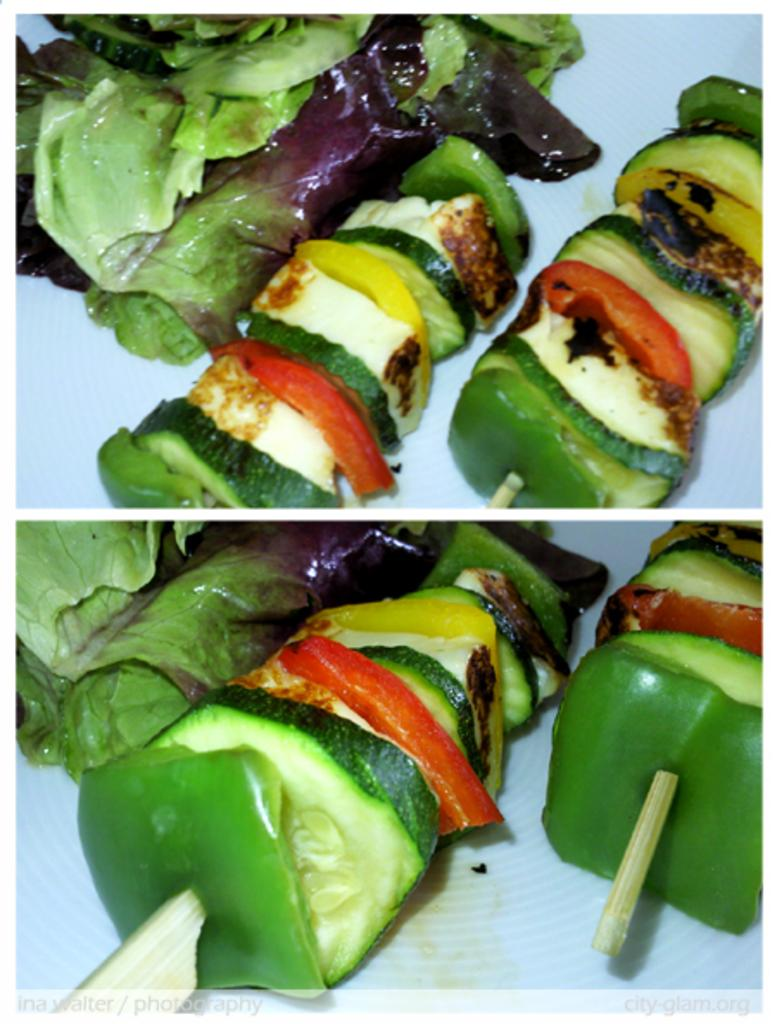What type of image is displayed in the collage? The collage contains a picture of a group of food items. How are the food items arranged in the picture? The food items are placed on a stick. What type of chair is visible in the image? There is no chair present in the image; it only contains a collage of a picture with food items on a stick. 